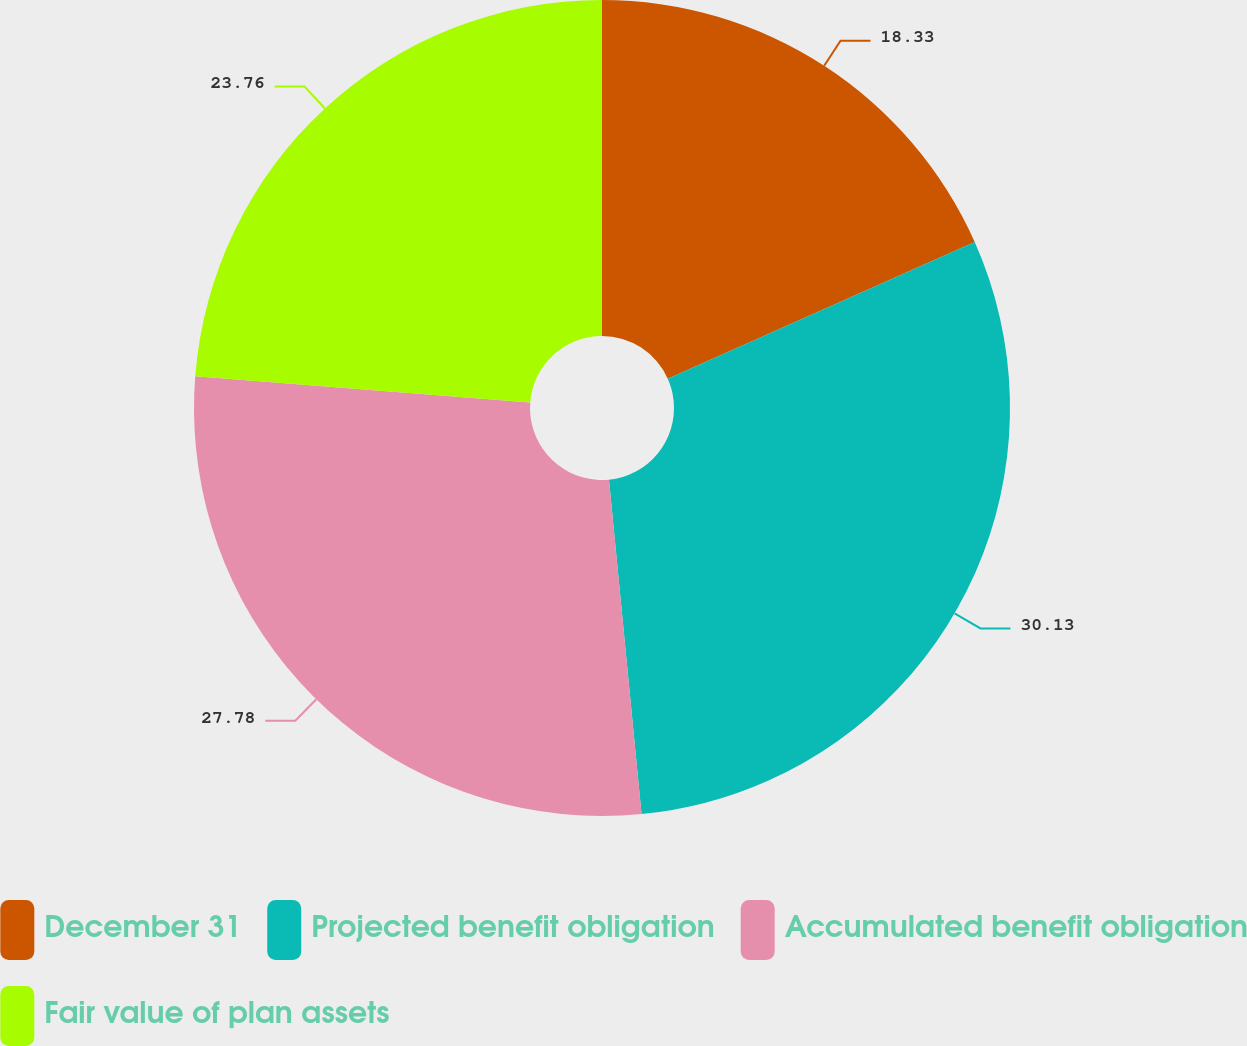<chart> <loc_0><loc_0><loc_500><loc_500><pie_chart><fcel>December 31<fcel>Projected benefit obligation<fcel>Accumulated benefit obligation<fcel>Fair value of plan assets<nl><fcel>18.33%<fcel>30.12%<fcel>27.78%<fcel>23.76%<nl></chart> 